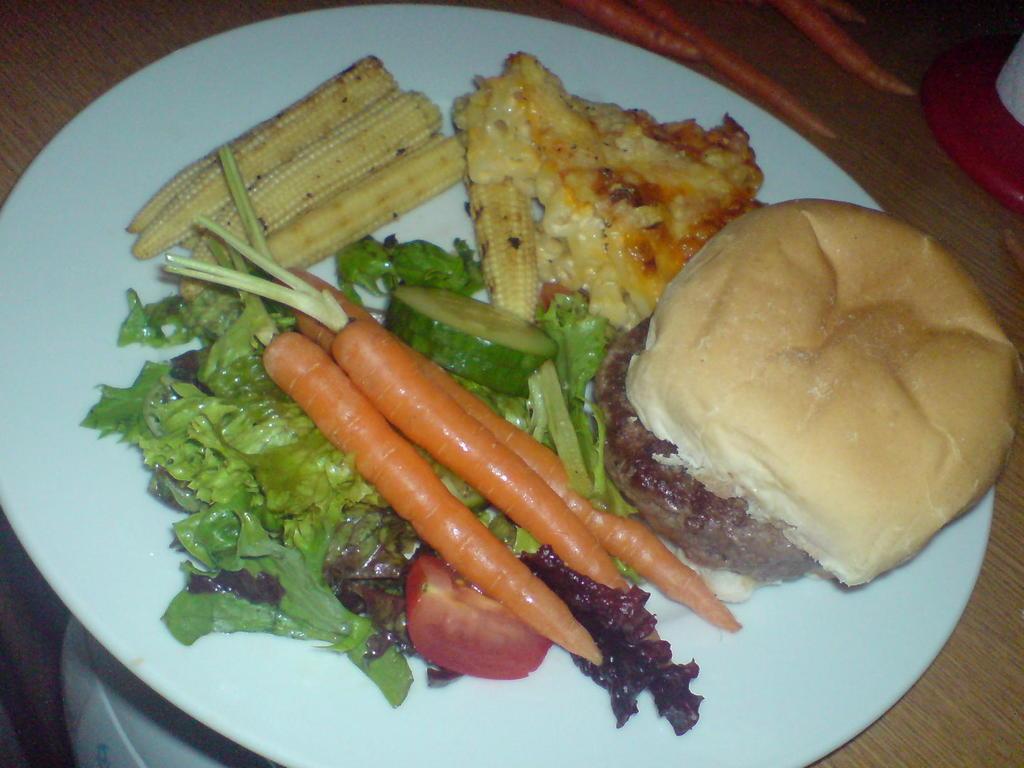How would you summarize this image in a sentence or two? In this picture we can see food in a plate and this plate is on a wooden platform and in the background we can see carrots and an object. 